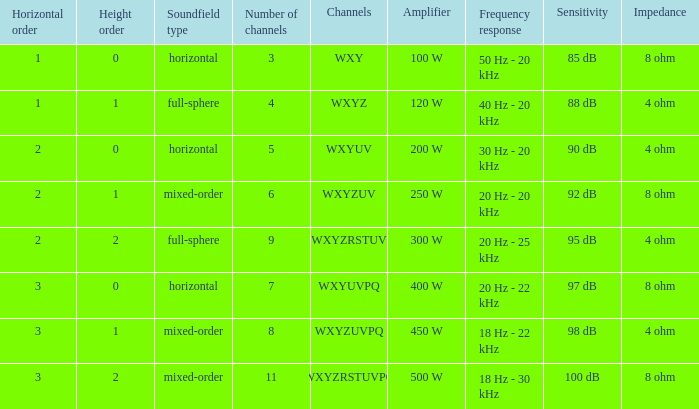If the channels is wxyzrstuvpq, what is the horizontal order? 3.0. 